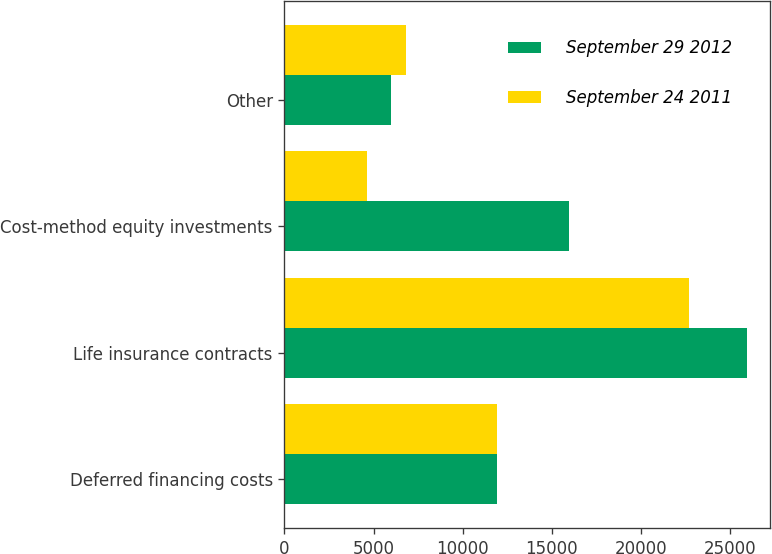<chart> <loc_0><loc_0><loc_500><loc_500><stacked_bar_chart><ecel><fcel>Deferred financing costs<fcel>Life insurance contracts<fcel>Cost-method equity investments<fcel>Other<nl><fcel>September 29 2012<fcel>11918<fcel>25978<fcel>15976<fcel>6006<nl><fcel>September 24 2011<fcel>11918<fcel>22736<fcel>4608<fcel>6815<nl></chart> 